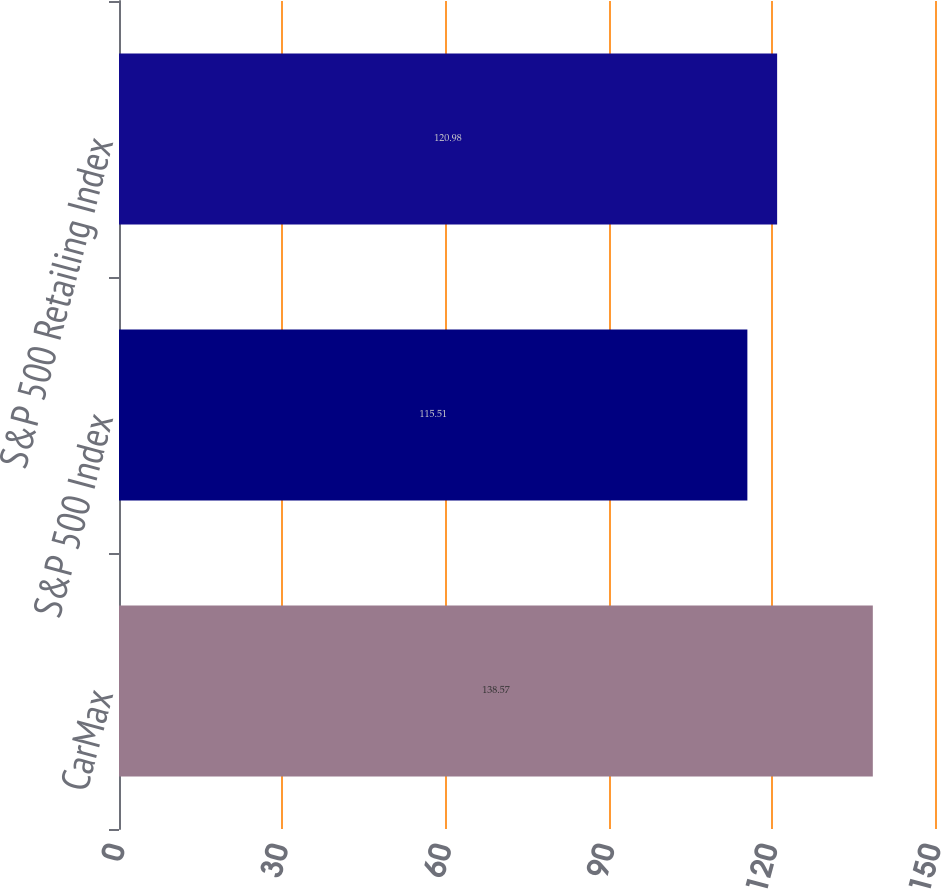Convert chart. <chart><loc_0><loc_0><loc_500><loc_500><bar_chart><fcel>CarMax<fcel>S&P 500 Index<fcel>S&P 500 Retailing Index<nl><fcel>138.57<fcel>115.51<fcel>120.98<nl></chart> 